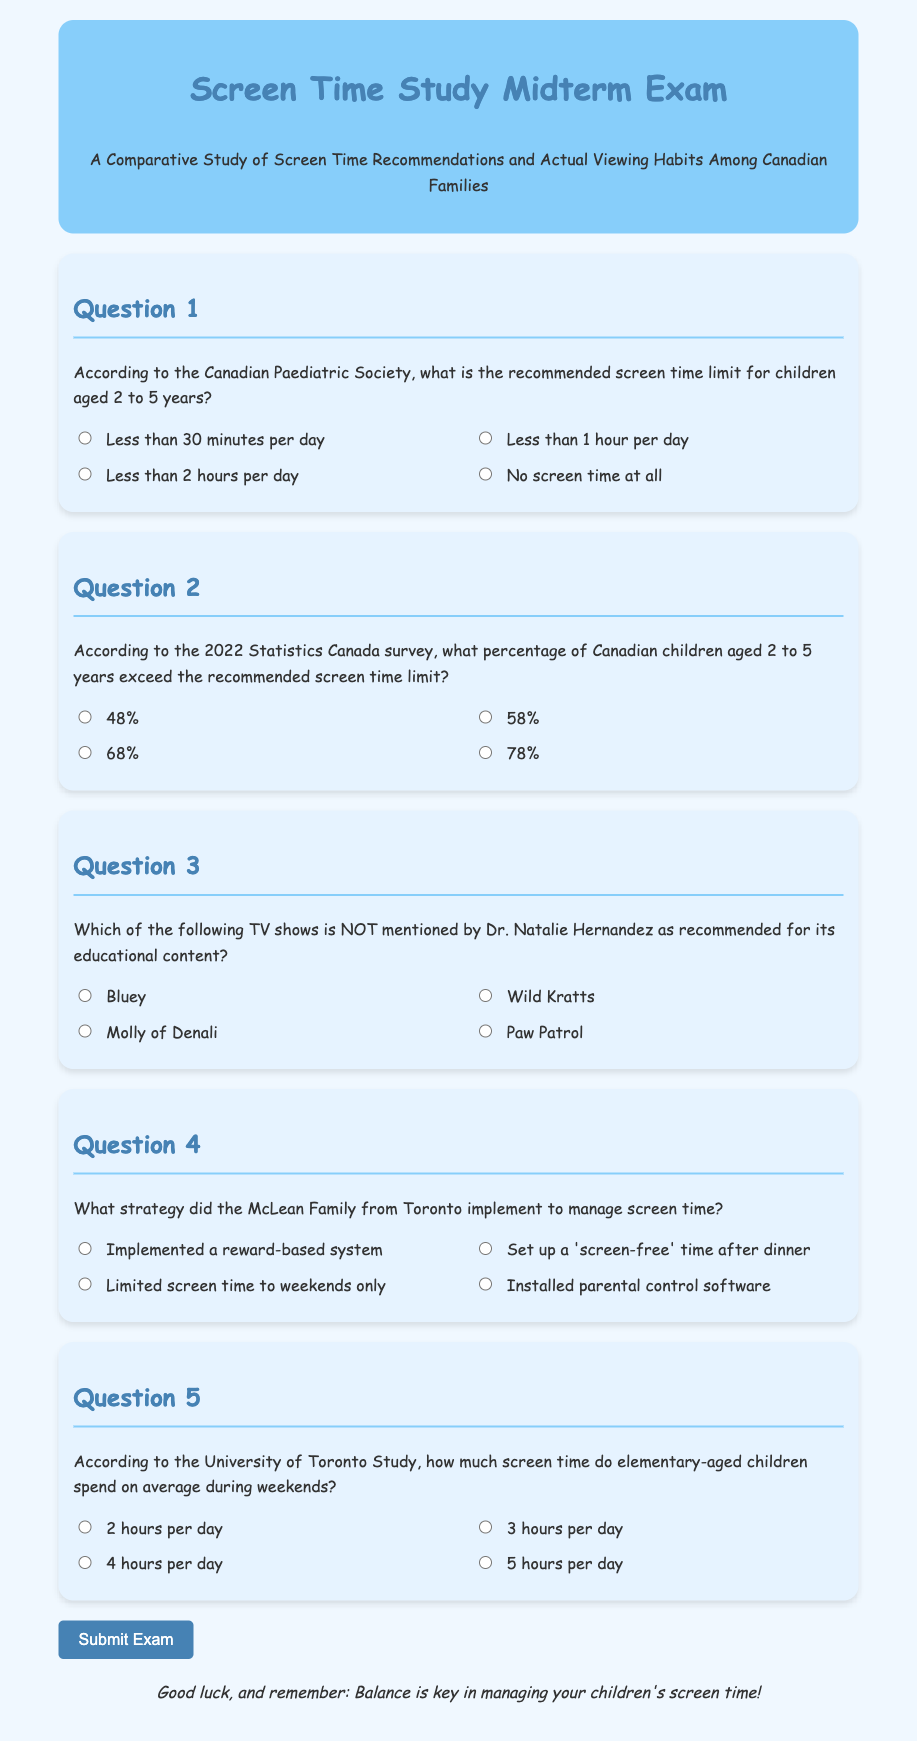What is the recommended screen time limit for children aged 2 to 5 years? The Canadian Paediatric Society recommends less than 1 hour per day for children aged 2 to 5 years.
Answer: Less than 1 hour per day What percentage of Canadian children aged 2 to 5 years exceed the recommended screen time limit? According to the 2022 Statistics Canada survey, 58% of Canadian children aged 2 to 5 years exceed the recommended screen time limit.
Answer: 58% Which TV show is NOT mentioned by Dr. Natalie Hernandez as recommended? Dr. Natalie Hernandez does not mention Paw Patrol as recommended for educational content.
Answer: Paw Patrol What strategy did the McLean Family implement to manage screen time? The McLean Family set up a 'screen-free' time after dinner to manage screen time.
Answer: 'Screen-free' time after dinner How much screen time do elementary-aged children spend on average during weekends? According to the University of Toronto Study, elementary-aged children spend an average of 3 hours per day on screen time during weekends.
Answer: 3 hours per day 